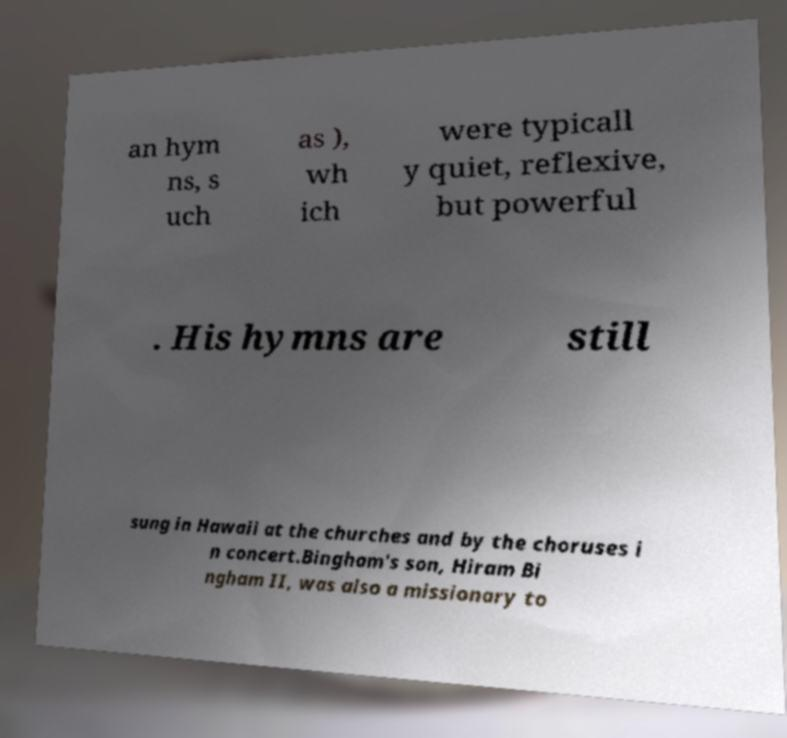Can you accurately transcribe the text from the provided image for me? an hym ns, s uch as ), wh ich were typicall y quiet, reflexive, but powerful . His hymns are still sung in Hawaii at the churches and by the choruses i n concert.Bingham's son, Hiram Bi ngham II, was also a missionary to 